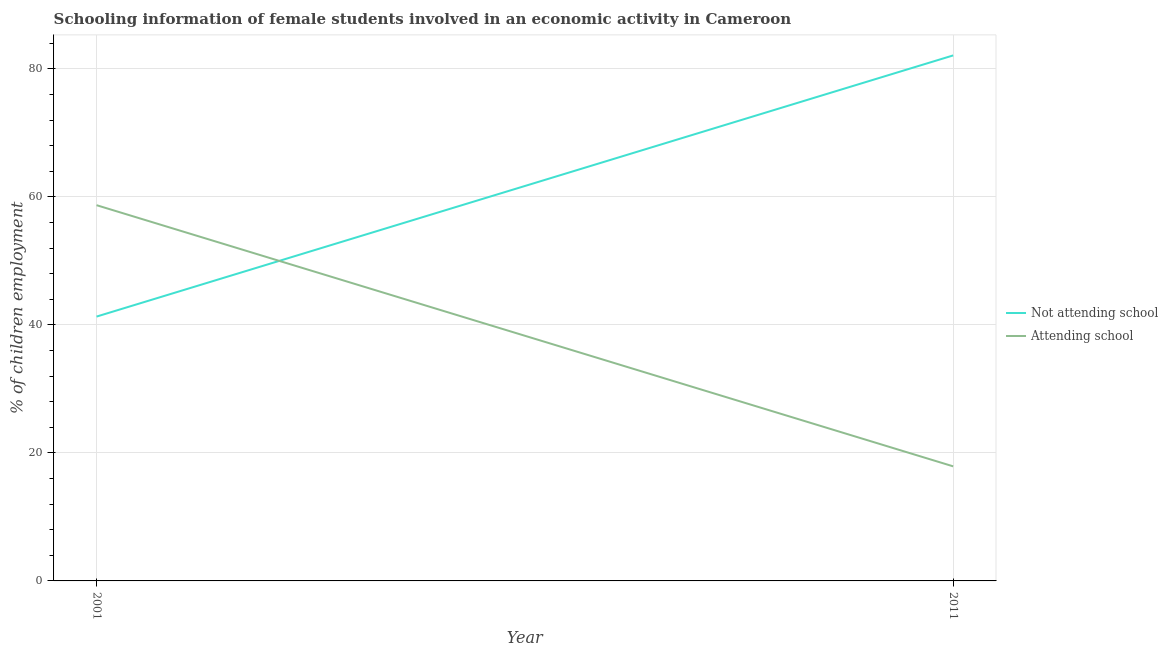How many different coloured lines are there?
Keep it short and to the point. 2. What is the percentage of employed females who are not attending school in 2011?
Offer a terse response. 82.1. Across all years, what is the maximum percentage of employed females who are attending school?
Keep it short and to the point. 58.7. In which year was the percentage of employed females who are not attending school maximum?
Provide a succinct answer. 2011. In which year was the percentage of employed females who are attending school minimum?
Your answer should be compact. 2011. What is the total percentage of employed females who are not attending school in the graph?
Your answer should be compact. 123.4. What is the difference between the percentage of employed females who are attending school in 2001 and that in 2011?
Provide a short and direct response. 40.8. What is the difference between the percentage of employed females who are not attending school in 2011 and the percentage of employed females who are attending school in 2001?
Keep it short and to the point. 23.4. What is the average percentage of employed females who are not attending school per year?
Your response must be concise. 61.7. In the year 2001, what is the difference between the percentage of employed females who are attending school and percentage of employed females who are not attending school?
Offer a very short reply. 17.41. What is the ratio of the percentage of employed females who are not attending school in 2001 to that in 2011?
Give a very brief answer. 0.5. In how many years, is the percentage of employed females who are not attending school greater than the average percentage of employed females who are not attending school taken over all years?
Ensure brevity in your answer.  1. Does the percentage of employed females who are attending school monotonically increase over the years?
Offer a very short reply. No. Is the percentage of employed females who are attending school strictly less than the percentage of employed females who are not attending school over the years?
Offer a terse response. No. How many lines are there?
Provide a short and direct response. 2. How many years are there in the graph?
Your response must be concise. 2. Does the graph contain any zero values?
Ensure brevity in your answer.  No. Does the graph contain grids?
Provide a short and direct response. Yes. Where does the legend appear in the graph?
Ensure brevity in your answer.  Center right. How many legend labels are there?
Your response must be concise. 2. What is the title of the graph?
Keep it short and to the point. Schooling information of female students involved in an economic activity in Cameroon. What is the label or title of the Y-axis?
Make the answer very short. % of children employment. What is the % of children employment in Not attending school in 2001?
Offer a terse response. 41.3. What is the % of children employment in Attending school in 2001?
Make the answer very short. 58.7. What is the % of children employment of Not attending school in 2011?
Ensure brevity in your answer.  82.1. What is the % of children employment of Attending school in 2011?
Offer a very short reply. 17.9. Across all years, what is the maximum % of children employment in Not attending school?
Provide a short and direct response. 82.1. Across all years, what is the maximum % of children employment of Attending school?
Your answer should be compact. 58.7. Across all years, what is the minimum % of children employment of Not attending school?
Ensure brevity in your answer.  41.3. Across all years, what is the minimum % of children employment in Attending school?
Keep it short and to the point. 17.9. What is the total % of children employment of Not attending school in the graph?
Give a very brief answer. 123.4. What is the total % of children employment in Attending school in the graph?
Make the answer very short. 76.6. What is the difference between the % of children employment in Not attending school in 2001 and that in 2011?
Keep it short and to the point. -40.8. What is the difference between the % of children employment of Attending school in 2001 and that in 2011?
Your answer should be compact. 40.8. What is the difference between the % of children employment in Not attending school in 2001 and the % of children employment in Attending school in 2011?
Make the answer very short. 23.4. What is the average % of children employment of Not attending school per year?
Give a very brief answer. 61.7. What is the average % of children employment of Attending school per year?
Your answer should be compact. 38.3. In the year 2001, what is the difference between the % of children employment of Not attending school and % of children employment of Attending school?
Ensure brevity in your answer.  -17.41. In the year 2011, what is the difference between the % of children employment in Not attending school and % of children employment in Attending school?
Provide a succinct answer. 64.2. What is the ratio of the % of children employment in Not attending school in 2001 to that in 2011?
Ensure brevity in your answer.  0.5. What is the ratio of the % of children employment in Attending school in 2001 to that in 2011?
Your answer should be compact. 3.28. What is the difference between the highest and the second highest % of children employment in Not attending school?
Provide a short and direct response. 40.8. What is the difference between the highest and the second highest % of children employment of Attending school?
Ensure brevity in your answer.  40.8. What is the difference between the highest and the lowest % of children employment of Not attending school?
Your answer should be compact. 40.8. What is the difference between the highest and the lowest % of children employment in Attending school?
Your answer should be compact. 40.8. 